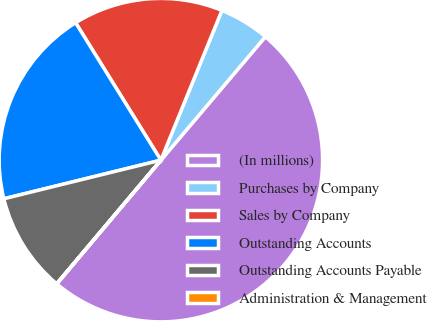<chart> <loc_0><loc_0><loc_500><loc_500><pie_chart><fcel>(In millions)<fcel>Purchases by Company<fcel>Sales by Company<fcel>Outstanding Accounts<fcel>Outstanding Accounts Payable<fcel>Administration & Management<nl><fcel>49.95%<fcel>5.02%<fcel>15.0%<fcel>20.0%<fcel>10.01%<fcel>0.02%<nl></chart> 